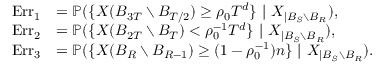<formula> <loc_0><loc_0><loc_500><loc_500>\begin{array} { r l } { E r r _ { 1 } } & { = \mathbb { P } ( \{ X ( B _ { 3 T } \ B _ { T / 2 } ) \geq \rho _ { 0 } T ^ { d } \} \ | \ X _ { | B _ { S } \ B _ { R } } ) , } \\ { E r r _ { 2 } } & { = \mathbb { P } ( \{ X ( B _ { 2 T } \ B _ { T } ) < \rho _ { 0 } ^ { - 1 } T ^ { d } \} \ | \ X _ { | B _ { S } \ B _ { R } } ) , } \\ { E r r _ { 3 } } & { = \mathbb { P } ( \{ X ( B _ { R } \ B _ { R - 1 } ) \geq ( 1 - \rho _ { 0 } ^ { - 1 } ) n \} \ | \ X _ { | B _ { S } \ B _ { R } } ) . } \end{array}</formula> 